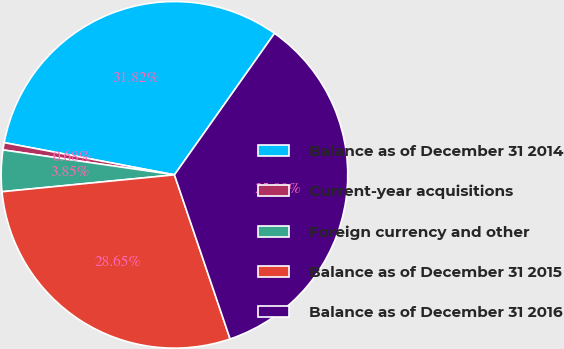Convert chart. <chart><loc_0><loc_0><loc_500><loc_500><pie_chart><fcel>Balance as of December 31 2014<fcel>Current-year acquisitions<fcel>Foreign currency and other<fcel>Balance as of December 31 2015<fcel>Balance as of December 31 2016<nl><fcel>31.82%<fcel>0.68%<fcel>3.85%<fcel>28.65%<fcel>35.0%<nl></chart> 